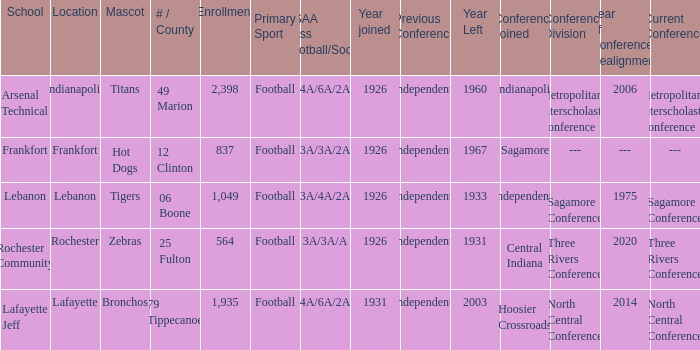What is the highest enrollment for rochester community school? 564.0. 